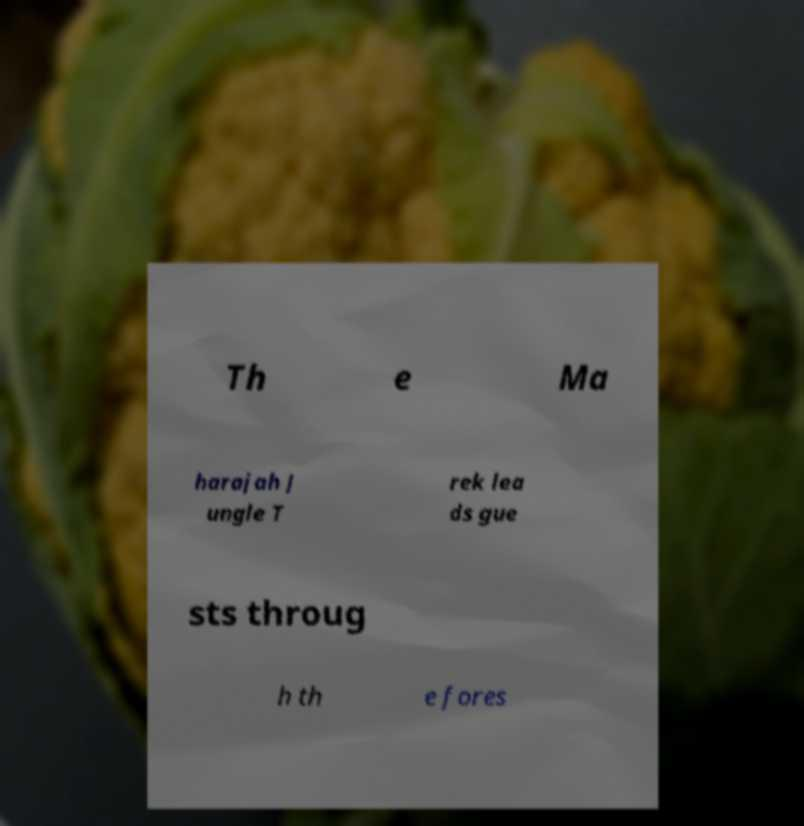Could you assist in decoding the text presented in this image and type it out clearly? Th e Ma harajah J ungle T rek lea ds gue sts throug h th e fores 